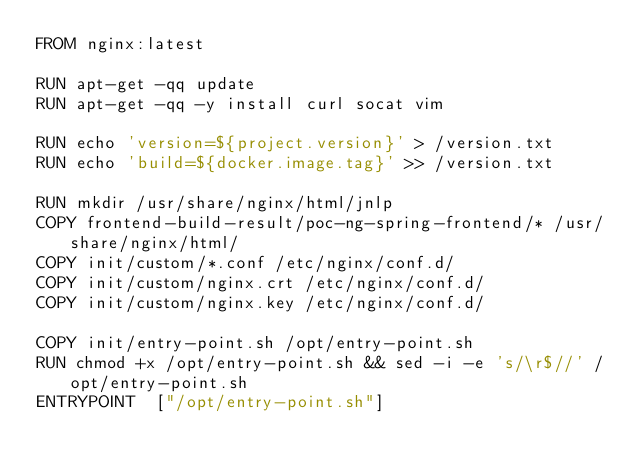Convert code to text. <code><loc_0><loc_0><loc_500><loc_500><_Dockerfile_>FROM nginx:latest

RUN apt-get -qq update
RUN apt-get -qq -y install curl socat vim

RUN echo 'version=${project.version}' > /version.txt
RUN echo 'build=${docker.image.tag}' >> /version.txt

RUN mkdir /usr/share/nginx/html/jnlp
COPY frontend-build-result/poc-ng-spring-frontend/* /usr/share/nginx/html/
COPY init/custom/*.conf /etc/nginx/conf.d/
COPY init/custom/nginx.crt /etc/nginx/conf.d/
COPY init/custom/nginx.key /etc/nginx/conf.d/

COPY init/entry-point.sh /opt/entry-point.sh
RUN chmod +x /opt/entry-point.sh && sed -i -e 's/\r$//' /opt/entry-point.sh
ENTRYPOINT  ["/opt/entry-point.sh"]</code> 